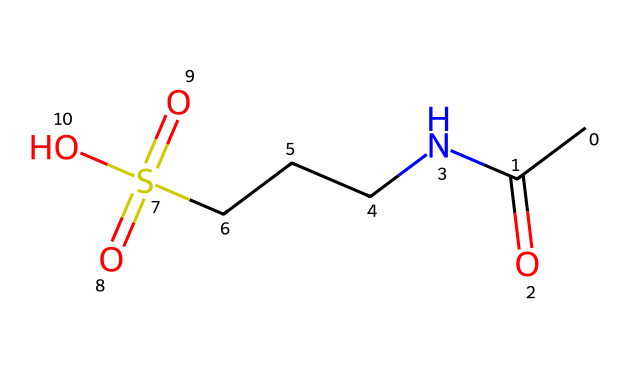What is the total number of carbon atoms present in acamprosate? The SMILES representation includes "CC" at the beginning, indicating two carbon atoms followed by "NCC" which adds another carbon atom, making a total of three. Thus, there are three carbon atoms in the entire structure.
Answer: three How many sulfur atoms are present in the chemical structure? The SMILES includes "S(=O)(=O)", indicating the presence of one sulfur atom with two double-bonded oxygens associated with it. Therefore, there is one sulfur atom in the structure.
Answer: one What is the functional group of the sulfonic acid in acamprosate? The presence of "S(=O)(=O)O" in the SMILES indicates that the compound has a sulfonic acid functional group, characterized by a sulfur atom bonded to three oxygens, with one of which is an -OH group.
Answer: sulfonic acid What type of chemical bond connects the nitrogen atom to the carbon chain? The "NCC" in the SMILES indicates that there is a single covalent bond connecting the nitrogen (N) to the carbon chain since no double bond is specified.
Answer: single bond How many oxygen atoms are part of the acamprosate structure? In the SMILES representation "S(=O)(=O)O", there are three oxygen atoms attached to sulfur, and an additional oxygen from "CC(=O)", totaling four oxygen atoms in the structure.
Answer: four 